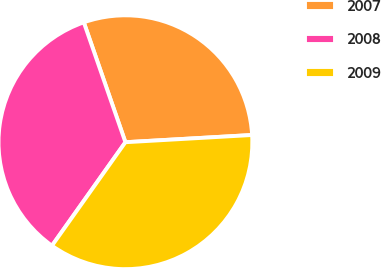Convert chart to OTSL. <chart><loc_0><loc_0><loc_500><loc_500><pie_chart><fcel>2007<fcel>2008<fcel>2009<nl><fcel>29.41%<fcel>34.86%<fcel>35.73%<nl></chart> 